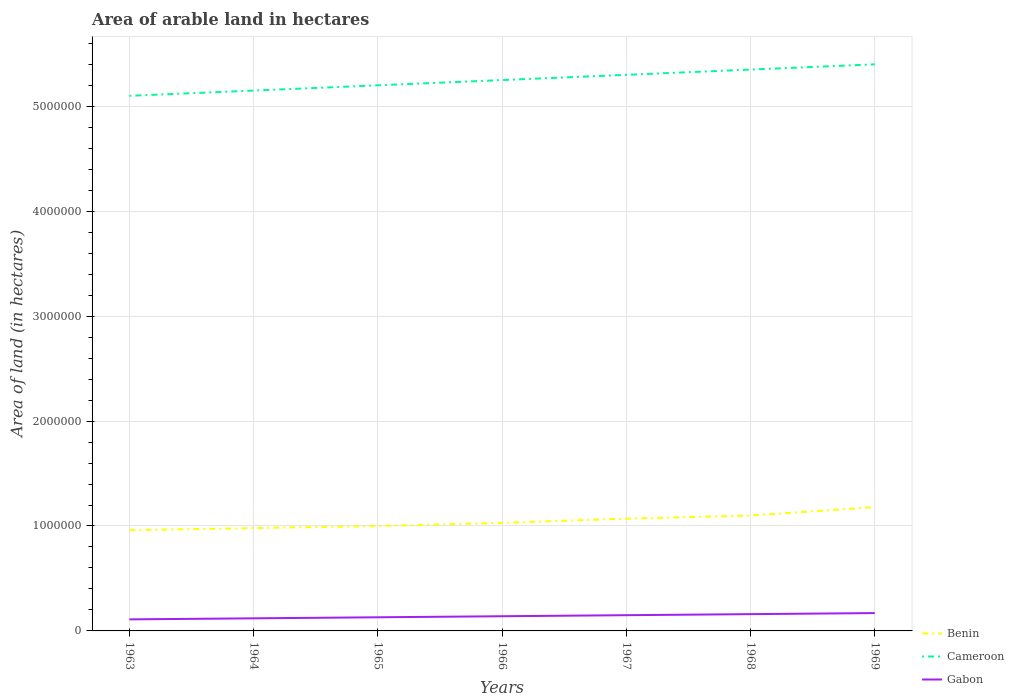How many different coloured lines are there?
Offer a very short reply. 3. Does the line corresponding to Gabon intersect with the line corresponding to Cameroon?
Your answer should be very brief. No. Across all years, what is the maximum total arable land in Gabon?
Keep it short and to the point. 1.10e+05. In which year was the total arable land in Benin maximum?
Provide a short and direct response. 1963. What is the total total arable land in Gabon in the graph?
Make the answer very short. -10000. What is the difference between the highest and the second highest total arable land in Gabon?
Provide a succinct answer. 6.00e+04. What is the difference between the highest and the lowest total arable land in Benin?
Offer a terse response. 3. Is the total arable land in Gabon strictly greater than the total arable land in Benin over the years?
Offer a very short reply. Yes. How many lines are there?
Your answer should be compact. 3. How many years are there in the graph?
Make the answer very short. 7. Does the graph contain grids?
Your response must be concise. Yes. Where does the legend appear in the graph?
Provide a short and direct response. Bottom right. How many legend labels are there?
Offer a very short reply. 3. What is the title of the graph?
Provide a succinct answer. Area of arable land in hectares. Does "Curacao" appear as one of the legend labels in the graph?
Your response must be concise. No. What is the label or title of the X-axis?
Ensure brevity in your answer.  Years. What is the label or title of the Y-axis?
Make the answer very short. Area of land (in hectares). What is the Area of land (in hectares) in Benin in 1963?
Your answer should be very brief. 9.60e+05. What is the Area of land (in hectares) of Cameroon in 1963?
Keep it short and to the point. 5.10e+06. What is the Area of land (in hectares) in Benin in 1964?
Keep it short and to the point. 9.80e+05. What is the Area of land (in hectares) in Cameroon in 1964?
Keep it short and to the point. 5.15e+06. What is the Area of land (in hectares) of Benin in 1965?
Make the answer very short. 1.00e+06. What is the Area of land (in hectares) in Cameroon in 1965?
Provide a short and direct response. 5.20e+06. What is the Area of land (in hectares) of Gabon in 1965?
Your response must be concise. 1.30e+05. What is the Area of land (in hectares) in Benin in 1966?
Your response must be concise. 1.03e+06. What is the Area of land (in hectares) of Cameroon in 1966?
Provide a succinct answer. 5.25e+06. What is the Area of land (in hectares) in Benin in 1967?
Ensure brevity in your answer.  1.07e+06. What is the Area of land (in hectares) of Cameroon in 1967?
Make the answer very short. 5.30e+06. What is the Area of land (in hectares) of Benin in 1968?
Give a very brief answer. 1.10e+06. What is the Area of land (in hectares) in Cameroon in 1968?
Provide a succinct answer. 5.35e+06. What is the Area of land (in hectares) in Gabon in 1968?
Your answer should be compact. 1.60e+05. What is the Area of land (in hectares) in Benin in 1969?
Provide a short and direct response. 1.18e+06. What is the Area of land (in hectares) in Cameroon in 1969?
Offer a terse response. 5.40e+06. Across all years, what is the maximum Area of land (in hectares) in Benin?
Keep it short and to the point. 1.18e+06. Across all years, what is the maximum Area of land (in hectares) in Cameroon?
Your answer should be compact. 5.40e+06. Across all years, what is the maximum Area of land (in hectares) of Gabon?
Provide a succinct answer. 1.70e+05. Across all years, what is the minimum Area of land (in hectares) in Benin?
Make the answer very short. 9.60e+05. Across all years, what is the minimum Area of land (in hectares) in Cameroon?
Your response must be concise. 5.10e+06. Across all years, what is the minimum Area of land (in hectares) of Gabon?
Make the answer very short. 1.10e+05. What is the total Area of land (in hectares) in Benin in the graph?
Your response must be concise. 7.32e+06. What is the total Area of land (in hectares) of Cameroon in the graph?
Your answer should be compact. 3.68e+07. What is the total Area of land (in hectares) in Gabon in the graph?
Offer a terse response. 9.80e+05. What is the difference between the Area of land (in hectares) in Cameroon in 1963 and that in 1964?
Keep it short and to the point. -5.00e+04. What is the difference between the Area of land (in hectares) in Gabon in 1963 and that in 1964?
Keep it short and to the point. -10000. What is the difference between the Area of land (in hectares) in Cameroon in 1963 and that in 1965?
Provide a short and direct response. -1.00e+05. What is the difference between the Area of land (in hectares) in Gabon in 1963 and that in 1965?
Your answer should be very brief. -2.00e+04. What is the difference between the Area of land (in hectares) in Benin in 1963 and that in 1966?
Ensure brevity in your answer.  -7.00e+04. What is the difference between the Area of land (in hectares) of Gabon in 1963 and that in 1966?
Ensure brevity in your answer.  -3.00e+04. What is the difference between the Area of land (in hectares) of Benin in 1963 and that in 1967?
Keep it short and to the point. -1.10e+05. What is the difference between the Area of land (in hectares) of Gabon in 1963 and that in 1968?
Keep it short and to the point. -5.00e+04. What is the difference between the Area of land (in hectares) of Cameroon in 1963 and that in 1969?
Keep it short and to the point. -3.00e+05. What is the difference between the Area of land (in hectares) in Gabon in 1963 and that in 1969?
Ensure brevity in your answer.  -6.00e+04. What is the difference between the Area of land (in hectares) of Gabon in 1964 and that in 1965?
Provide a short and direct response. -10000. What is the difference between the Area of land (in hectares) of Benin in 1964 and that in 1966?
Your answer should be compact. -5.00e+04. What is the difference between the Area of land (in hectares) of Cameroon in 1964 and that in 1966?
Your response must be concise. -1.00e+05. What is the difference between the Area of land (in hectares) of Gabon in 1964 and that in 1966?
Provide a short and direct response. -2.00e+04. What is the difference between the Area of land (in hectares) in Benin in 1964 and that in 1967?
Keep it short and to the point. -9.00e+04. What is the difference between the Area of land (in hectares) in Cameroon in 1964 and that in 1967?
Offer a very short reply. -1.50e+05. What is the difference between the Area of land (in hectares) in Cameroon in 1964 and that in 1968?
Give a very brief answer. -2.00e+05. What is the difference between the Area of land (in hectares) in Gabon in 1964 and that in 1969?
Provide a short and direct response. -5.00e+04. What is the difference between the Area of land (in hectares) of Benin in 1965 and that in 1966?
Offer a very short reply. -3.00e+04. What is the difference between the Area of land (in hectares) of Benin in 1965 and that in 1967?
Provide a succinct answer. -7.00e+04. What is the difference between the Area of land (in hectares) in Cameroon in 1965 and that in 1967?
Ensure brevity in your answer.  -1.00e+05. What is the difference between the Area of land (in hectares) in Gabon in 1965 and that in 1969?
Your answer should be compact. -4.00e+04. What is the difference between the Area of land (in hectares) of Gabon in 1966 and that in 1967?
Provide a succinct answer. -10000. What is the difference between the Area of land (in hectares) in Cameroon in 1966 and that in 1968?
Your response must be concise. -1.00e+05. What is the difference between the Area of land (in hectares) of Gabon in 1966 and that in 1968?
Your response must be concise. -2.00e+04. What is the difference between the Area of land (in hectares) of Benin in 1966 and that in 1969?
Ensure brevity in your answer.  -1.50e+05. What is the difference between the Area of land (in hectares) of Cameroon in 1966 and that in 1969?
Your response must be concise. -1.50e+05. What is the difference between the Area of land (in hectares) in Gabon in 1966 and that in 1969?
Your answer should be very brief. -3.00e+04. What is the difference between the Area of land (in hectares) of Benin in 1967 and that in 1968?
Your answer should be compact. -3.00e+04. What is the difference between the Area of land (in hectares) in Cameroon in 1967 and that in 1969?
Ensure brevity in your answer.  -1.00e+05. What is the difference between the Area of land (in hectares) of Benin in 1968 and that in 1969?
Offer a very short reply. -8.00e+04. What is the difference between the Area of land (in hectares) of Gabon in 1968 and that in 1969?
Provide a succinct answer. -10000. What is the difference between the Area of land (in hectares) of Benin in 1963 and the Area of land (in hectares) of Cameroon in 1964?
Give a very brief answer. -4.19e+06. What is the difference between the Area of land (in hectares) in Benin in 1963 and the Area of land (in hectares) in Gabon in 1964?
Offer a very short reply. 8.40e+05. What is the difference between the Area of land (in hectares) of Cameroon in 1963 and the Area of land (in hectares) of Gabon in 1964?
Provide a succinct answer. 4.98e+06. What is the difference between the Area of land (in hectares) of Benin in 1963 and the Area of land (in hectares) of Cameroon in 1965?
Give a very brief answer. -4.24e+06. What is the difference between the Area of land (in hectares) of Benin in 1963 and the Area of land (in hectares) of Gabon in 1965?
Your answer should be compact. 8.30e+05. What is the difference between the Area of land (in hectares) in Cameroon in 1963 and the Area of land (in hectares) in Gabon in 1965?
Give a very brief answer. 4.97e+06. What is the difference between the Area of land (in hectares) in Benin in 1963 and the Area of land (in hectares) in Cameroon in 1966?
Provide a short and direct response. -4.29e+06. What is the difference between the Area of land (in hectares) in Benin in 1963 and the Area of land (in hectares) in Gabon in 1966?
Ensure brevity in your answer.  8.20e+05. What is the difference between the Area of land (in hectares) of Cameroon in 1963 and the Area of land (in hectares) of Gabon in 1966?
Keep it short and to the point. 4.96e+06. What is the difference between the Area of land (in hectares) in Benin in 1963 and the Area of land (in hectares) in Cameroon in 1967?
Ensure brevity in your answer.  -4.34e+06. What is the difference between the Area of land (in hectares) of Benin in 1963 and the Area of land (in hectares) of Gabon in 1967?
Offer a terse response. 8.10e+05. What is the difference between the Area of land (in hectares) in Cameroon in 1963 and the Area of land (in hectares) in Gabon in 1967?
Give a very brief answer. 4.95e+06. What is the difference between the Area of land (in hectares) in Benin in 1963 and the Area of land (in hectares) in Cameroon in 1968?
Make the answer very short. -4.39e+06. What is the difference between the Area of land (in hectares) in Cameroon in 1963 and the Area of land (in hectares) in Gabon in 1968?
Make the answer very short. 4.94e+06. What is the difference between the Area of land (in hectares) of Benin in 1963 and the Area of land (in hectares) of Cameroon in 1969?
Make the answer very short. -4.44e+06. What is the difference between the Area of land (in hectares) in Benin in 1963 and the Area of land (in hectares) in Gabon in 1969?
Offer a very short reply. 7.90e+05. What is the difference between the Area of land (in hectares) of Cameroon in 1963 and the Area of land (in hectares) of Gabon in 1969?
Give a very brief answer. 4.93e+06. What is the difference between the Area of land (in hectares) of Benin in 1964 and the Area of land (in hectares) of Cameroon in 1965?
Ensure brevity in your answer.  -4.22e+06. What is the difference between the Area of land (in hectares) in Benin in 1964 and the Area of land (in hectares) in Gabon in 1965?
Keep it short and to the point. 8.50e+05. What is the difference between the Area of land (in hectares) of Cameroon in 1964 and the Area of land (in hectares) of Gabon in 1965?
Your answer should be compact. 5.02e+06. What is the difference between the Area of land (in hectares) in Benin in 1964 and the Area of land (in hectares) in Cameroon in 1966?
Keep it short and to the point. -4.27e+06. What is the difference between the Area of land (in hectares) of Benin in 1964 and the Area of land (in hectares) of Gabon in 1966?
Provide a succinct answer. 8.40e+05. What is the difference between the Area of land (in hectares) in Cameroon in 1964 and the Area of land (in hectares) in Gabon in 1966?
Offer a very short reply. 5.01e+06. What is the difference between the Area of land (in hectares) in Benin in 1964 and the Area of land (in hectares) in Cameroon in 1967?
Keep it short and to the point. -4.32e+06. What is the difference between the Area of land (in hectares) in Benin in 1964 and the Area of land (in hectares) in Gabon in 1967?
Your answer should be compact. 8.30e+05. What is the difference between the Area of land (in hectares) in Cameroon in 1964 and the Area of land (in hectares) in Gabon in 1967?
Keep it short and to the point. 5.00e+06. What is the difference between the Area of land (in hectares) in Benin in 1964 and the Area of land (in hectares) in Cameroon in 1968?
Offer a very short reply. -4.37e+06. What is the difference between the Area of land (in hectares) in Benin in 1964 and the Area of land (in hectares) in Gabon in 1968?
Offer a terse response. 8.20e+05. What is the difference between the Area of land (in hectares) of Cameroon in 1964 and the Area of land (in hectares) of Gabon in 1968?
Ensure brevity in your answer.  4.99e+06. What is the difference between the Area of land (in hectares) of Benin in 1964 and the Area of land (in hectares) of Cameroon in 1969?
Give a very brief answer. -4.42e+06. What is the difference between the Area of land (in hectares) of Benin in 1964 and the Area of land (in hectares) of Gabon in 1969?
Keep it short and to the point. 8.10e+05. What is the difference between the Area of land (in hectares) of Cameroon in 1964 and the Area of land (in hectares) of Gabon in 1969?
Your answer should be compact. 4.98e+06. What is the difference between the Area of land (in hectares) in Benin in 1965 and the Area of land (in hectares) in Cameroon in 1966?
Your answer should be compact. -4.25e+06. What is the difference between the Area of land (in hectares) of Benin in 1965 and the Area of land (in hectares) of Gabon in 1966?
Offer a terse response. 8.60e+05. What is the difference between the Area of land (in hectares) of Cameroon in 1965 and the Area of land (in hectares) of Gabon in 1966?
Offer a very short reply. 5.06e+06. What is the difference between the Area of land (in hectares) of Benin in 1965 and the Area of land (in hectares) of Cameroon in 1967?
Offer a very short reply. -4.30e+06. What is the difference between the Area of land (in hectares) in Benin in 1965 and the Area of land (in hectares) in Gabon in 1967?
Your response must be concise. 8.50e+05. What is the difference between the Area of land (in hectares) of Cameroon in 1965 and the Area of land (in hectares) of Gabon in 1967?
Your answer should be very brief. 5.05e+06. What is the difference between the Area of land (in hectares) in Benin in 1965 and the Area of land (in hectares) in Cameroon in 1968?
Offer a terse response. -4.35e+06. What is the difference between the Area of land (in hectares) of Benin in 1965 and the Area of land (in hectares) of Gabon in 1968?
Provide a short and direct response. 8.40e+05. What is the difference between the Area of land (in hectares) in Cameroon in 1965 and the Area of land (in hectares) in Gabon in 1968?
Keep it short and to the point. 5.04e+06. What is the difference between the Area of land (in hectares) of Benin in 1965 and the Area of land (in hectares) of Cameroon in 1969?
Offer a very short reply. -4.40e+06. What is the difference between the Area of land (in hectares) of Benin in 1965 and the Area of land (in hectares) of Gabon in 1969?
Ensure brevity in your answer.  8.30e+05. What is the difference between the Area of land (in hectares) of Cameroon in 1965 and the Area of land (in hectares) of Gabon in 1969?
Offer a very short reply. 5.03e+06. What is the difference between the Area of land (in hectares) of Benin in 1966 and the Area of land (in hectares) of Cameroon in 1967?
Keep it short and to the point. -4.27e+06. What is the difference between the Area of land (in hectares) of Benin in 1966 and the Area of land (in hectares) of Gabon in 1967?
Your response must be concise. 8.80e+05. What is the difference between the Area of land (in hectares) of Cameroon in 1966 and the Area of land (in hectares) of Gabon in 1967?
Keep it short and to the point. 5.10e+06. What is the difference between the Area of land (in hectares) of Benin in 1966 and the Area of land (in hectares) of Cameroon in 1968?
Your answer should be compact. -4.32e+06. What is the difference between the Area of land (in hectares) in Benin in 1966 and the Area of land (in hectares) in Gabon in 1968?
Make the answer very short. 8.70e+05. What is the difference between the Area of land (in hectares) of Cameroon in 1966 and the Area of land (in hectares) of Gabon in 1968?
Your answer should be very brief. 5.09e+06. What is the difference between the Area of land (in hectares) in Benin in 1966 and the Area of land (in hectares) in Cameroon in 1969?
Give a very brief answer. -4.37e+06. What is the difference between the Area of land (in hectares) of Benin in 1966 and the Area of land (in hectares) of Gabon in 1969?
Provide a succinct answer. 8.60e+05. What is the difference between the Area of land (in hectares) in Cameroon in 1966 and the Area of land (in hectares) in Gabon in 1969?
Keep it short and to the point. 5.08e+06. What is the difference between the Area of land (in hectares) of Benin in 1967 and the Area of land (in hectares) of Cameroon in 1968?
Provide a short and direct response. -4.28e+06. What is the difference between the Area of land (in hectares) of Benin in 1967 and the Area of land (in hectares) of Gabon in 1968?
Make the answer very short. 9.10e+05. What is the difference between the Area of land (in hectares) in Cameroon in 1967 and the Area of land (in hectares) in Gabon in 1968?
Provide a succinct answer. 5.14e+06. What is the difference between the Area of land (in hectares) in Benin in 1967 and the Area of land (in hectares) in Cameroon in 1969?
Provide a succinct answer. -4.33e+06. What is the difference between the Area of land (in hectares) of Cameroon in 1967 and the Area of land (in hectares) of Gabon in 1969?
Provide a succinct answer. 5.13e+06. What is the difference between the Area of land (in hectares) of Benin in 1968 and the Area of land (in hectares) of Cameroon in 1969?
Ensure brevity in your answer.  -4.30e+06. What is the difference between the Area of land (in hectares) in Benin in 1968 and the Area of land (in hectares) in Gabon in 1969?
Your answer should be compact. 9.30e+05. What is the difference between the Area of land (in hectares) in Cameroon in 1968 and the Area of land (in hectares) in Gabon in 1969?
Provide a succinct answer. 5.18e+06. What is the average Area of land (in hectares) in Benin per year?
Your response must be concise. 1.05e+06. What is the average Area of land (in hectares) in Cameroon per year?
Provide a succinct answer. 5.25e+06. What is the average Area of land (in hectares) of Gabon per year?
Your answer should be compact. 1.40e+05. In the year 1963, what is the difference between the Area of land (in hectares) of Benin and Area of land (in hectares) of Cameroon?
Keep it short and to the point. -4.14e+06. In the year 1963, what is the difference between the Area of land (in hectares) in Benin and Area of land (in hectares) in Gabon?
Ensure brevity in your answer.  8.50e+05. In the year 1963, what is the difference between the Area of land (in hectares) of Cameroon and Area of land (in hectares) of Gabon?
Give a very brief answer. 4.99e+06. In the year 1964, what is the difference between the Area of land (in hectares) in Benin and Area of land (in hectares) in Cameroon?
Provide a succinct answer. -4.17e+06. In the year 1964, what is the difference between the Area of land (in hectares) in Benin and Area of land (in hectares) in Gabon?
Offer a terse response. 8.60e+05. In the year 1964, what is the difference between the Area of land (in hectares) of Cameroon and Area of land (in hectares) of Gabon?
Provide a short and direct response. 5.03e+06. In the year 1965, what is the difference between the Area of land (in hectares) of Benin and Area of land (in hectares) of Cameroon?
Provide a short and direct response. -4.20e+06. In the year 1965, what is the difference between the Area of land (in hectares) of Benin and Area of land (in hectares) of Gabon?
Offer a terse response. 8.70e+05. In the year 1965, what is the difference between the Area of land (in hectares) in Cameroon and Area of land (in hectares) in Gabon?
Give a very brief answer. 5.07e+06. In the year 1966, what is the difference between the Area of land (in hectares) in Benin and Area of land (in hectares) in Cameroon?
Provide a short and direct response. -4.22e+06. In the year 1966, what is the difference between the Area of land (in hectares) in Benin and Area of land (in hectares) in Gabon?
Offer a terse response. 8.90e+05. In the year 1966, what is the difference between the Area of land (in hectares) in Cameroon and Area of land (in hectares) in Gabon?
Offer a very short reply. 5.11e+06. In the year 1967, what is the difference between the Area of land (in hectares) of Benin and Area of land (in hectares) of Cameroon?
Offer a terse response. -4.23e+06. In the year 1967, what is the difference between the Area of land (in hectares) of Benin and Area of land (in hectares) of Gabon?
Make the answer very short. 9.20e+05. In the year 1967, what is the difference between the Area of land (in hectares) of Cameroon and Area of land (in hectares) of Gabon?
Make the answer very short. 5.15e+06. In the year 1968, what is the difference between the Area of land (in hectares) of Benin and Area of land (in hectares) of Cameroon?
Provide a short and direct response. -4.25e+06. In the year 1968, what is the difference between the Area of land (in hectares) in Benin and Area of land (in hectares) in Gabon?
Keep it short and to the point. 9.40e+05. In the year 1968, what is the difference between the Area of land (in hectares) in Cameroon and Area of land (in hectares) in Gabon?
Make the answer very short. 5.19e+06. In the year 1969, what is the difference between the Area of land (in hectares) in Benin and Area of land (in hectares) in Cameroon?
Ensure brevity in your answer.  -4.22e+06. In the year 1969, what is the difference between the Area of land (in hectares) in Benin and Area of land (in hectares) in Gabon?
Ensure brevity in your answer.  1.01e+06. In the year 1969, what is the difference between the Area of land (in hectares) of Cameroon and Area of land (in hectares) of Gabon?
Offer a very short reply. 5.23e+06. What is the ratio of the Area of land (in hectares) of Benin in 1963 to that in 1964?
Your answer should be compact. 0.98. What is the ratio of the Area of land (in hectares) of Cameroon in 1963 to that in 1964?
Give a very brief answer. 0.99. What is the ratio of the Area of land (in hectares) of Benin in 1963 to that in 1965?
Provide a succinct answer. 0.96. What is the ratio of the Area of land (in hectares) of Cameroon in 1963 to that in 1965?
Your answer should be very brief. 0.98. What is the ratio of the Area of land (in hectares) of Gabon in 1963 to that in 1965?
Provide a short and direct response. 0.85. What is the ratio of the Area of land (in hectares) in Benin in 1963 to that in 1966?
Give a very brief answer. 0.93. What is the ratio of the Area of land (in hectares) in Cameroon in 1963 to that in 1966?
Provide a succinct answer. 0.97. What is the ratio of the Area of land (in hectares) of Gabon in 1963 to that in 1966?
Keep it short and to the point. 0.79. What is the ratio of the Area of land (in hectares) in Benin in 1963 to that in 1967?
Provide a succinct answer. 0.9. What is the ratio of the Area of land (in hectares) of Cameroon in 1963 to that in 1967?
Make the answer very short. 0.96. What is the ratio of the Area of land (in hectares) in Gabon in 1963 to that in 1967?
Provide a succinct answer. 0.73. What is the ratio of the Area of land (in hectares) of Benin in 1963 to that in 1968?
Make the answer very short. 0.87. What is the ratio of the Area of land (in hectares) of Cameroon in 1963 to that in 1968?
Offer a terse response. 0.95. What is the ratio of the Area of land (in hectares) in Gabon in 1963 to that in 1968?
Keep it short and to the point. 0.69. What is the ratio of the Area of land (in hectares) in Benin in 1963 to that in 1969?
Give a very brief answer. 0.81. What is the ratio of the Area of land (in hectares) in Cameroon in 1963 to that in 1969?
Your response must be concise. 0.94. What is the ratio of the Area of land (in hectares) in Gabon in 1963 to that in 1969?
Make the answer very short. 0.65. What is the ratio of the Area of land (in hectares) of Benin in 1964 to that in 1965?
Ensure brevity in your answer.  0.98. What is the ratio of the Area of land (in hectares) of Cameroon in 1964 to that in 1965?
Ensure brevity in your answer.  0.99. What is the ratio of the Area of land (in hectares) in Gabon in 1964 to that in 1965?
Ensure brevity in your answer.  0.92. What is the ratio of the Area of land (in hectares) of Benin in 1964 to that in 1966?
Provide a succinct answer. 0.95. What is the ratio of the Area of land (in hectares) of Benin in 1964 to that in 1967?
Ensure brevity in your answer.  0.92. What is the ratio of the Area of land (in hectares) of Cameroon in 1964 to that in 1967?
Make the answer very short. 0.97. What is the ratio of the Area of land (in hectares) in Gabon in 1964 to that in 1967?
Offer a terse response. 0.8. What is the ratio of the Area of land (in hectares) in Benin in 1964 to that in 1968?
Keep it short and to the point. 0.89. What is the ratio of the Area of land (in hectares) in Cameroon in 1964 to that in 1968?
Provide a short and direct response. 0.96. What is the ratio of the Area of land (in hectares) of Gabon in 1964 to that in 1968?
Keep it short and to the point. 0.75. What is the ratio of the Area of land (in hectares) in Benin in 1964 to that in 1969?
Provide a succinct answer. 0.83. What is the ratio of the Area of land (in hectares) in Cameroon in 1964 to that in 1969?
Offer a terse response. 0.95. What is the ratio of the Area of land (in hectares) of Gabon in 1964 to that in 1969?
Your answer should be compact. 0.71. What is the ratio of the Area of land (in hectares) of Benin in 1965 to that in 1966?
Your answer should be compact. 0.97. What is the ratio of the Area of land (in hectares) of Cameroon in 1965 to that in 1966?
Offer a very short reply. 0.99. What is the ratio of the Area of land (in hectares) in Gabon in 1965 to that in 1966?
Your answer should be very brief. 0.93. What is the ratio of the Area of land (in hectares) of Benin in 1965 to that in 1967?
Provide a succinct answer. 0.93. What is the ratio of the Area of land (in hectares) in Cameroon in 1965 to that in 1967?
Your answer should be very brief. 0.98. What is the ratio of the Area of land (in hectares) in Gabon in 1965 to that in 1967?
Your response must be concise. 0.87. What is the ratio of the Area of land (in hectares) of Benin in 1965 to that in 1968?
Offer a very short reply. 0.91. What is the ratio of the Area of land (in hectares) in Cameroon in 1965 to that in 1968?
Make the answer very short. 0.97. What is the ratio of the Area of land (in hectares) of Gabon in 1965 to that in 1968?
Ensure brevity in your answer.  0.81. What is the ratio of the Area of land (in hectares) of Benin in 1965 to that in 1969?
Keep it short and to the point. 0.85. What is the ratio of the Area of land (in hectares) of Gabon in 1965 to that in 1969?
Ensure brevity in your answer.  0.76. What is the ratio of the Area of land (in hectares) of Benin in 1966 to that in 1967?
Ensure brevity in your answer.  0.96. What is the ratio of the Area of land (in hectares) of Cameroon in 1966 to that in 1967?
Your answer should be compact. 0.99. What is the ratio of the Area of land (in hectares) in Benin in 1966 to that in 1968?
Make the answer very short. 0.94. What is the ratio of the Area of land (in hectares) of Cameroon in 1966 to that in 1968?
Make the answer very short. 0.98. What is the ratio of the Area of land (in hectares) in Benin in 1966 to that in 1969?
Give a very brief answer. 0.87. What is the ratio of the Area of land (in hectares) in Cameroon in 1966 to that in 1969?
Provide a succinct answer. 0.97. What is the ratio of the Area of land (in hectares) of Gabon in 1966 to that in 1969?
Keep it short and to the point. 0.82. What is the ratio of the Area of land (in hectares) in Benin in 1967 to that in 1968?
Make the answer very short. 0.97. What is the ratio of the Area of land (in hectares) of Gabon in 1967 to that in 1968?
Your answer should be compact. 0.94. What is the ratio of the Area of land (in hectares) in Benin in 1967 to that in 1969?
Your answer should be compact. 0.91. What is the ratio of the Area of land (in hectares) of Cameroon in 1967 to that in 1969?
Offer a terse response. 0.98. What is the ratio of the Area of land (in hectares) of Gabon in 1967 to that in 1969?
Make the answer very short. 0.88. What is the ratio of the Area of land (in hectares) in Benin in 1968 to that in 1969?
Your answer should be very brief. 0.93. What is the difference between the highest and the lowest Area of land (in hectares) of Benin?
Offer a very short reply. 2.20e+05. What is the difference between the highest and the lowest Area of land (in hectares) in Cameroon?
Give a very brief answer. 3.00e+05. 